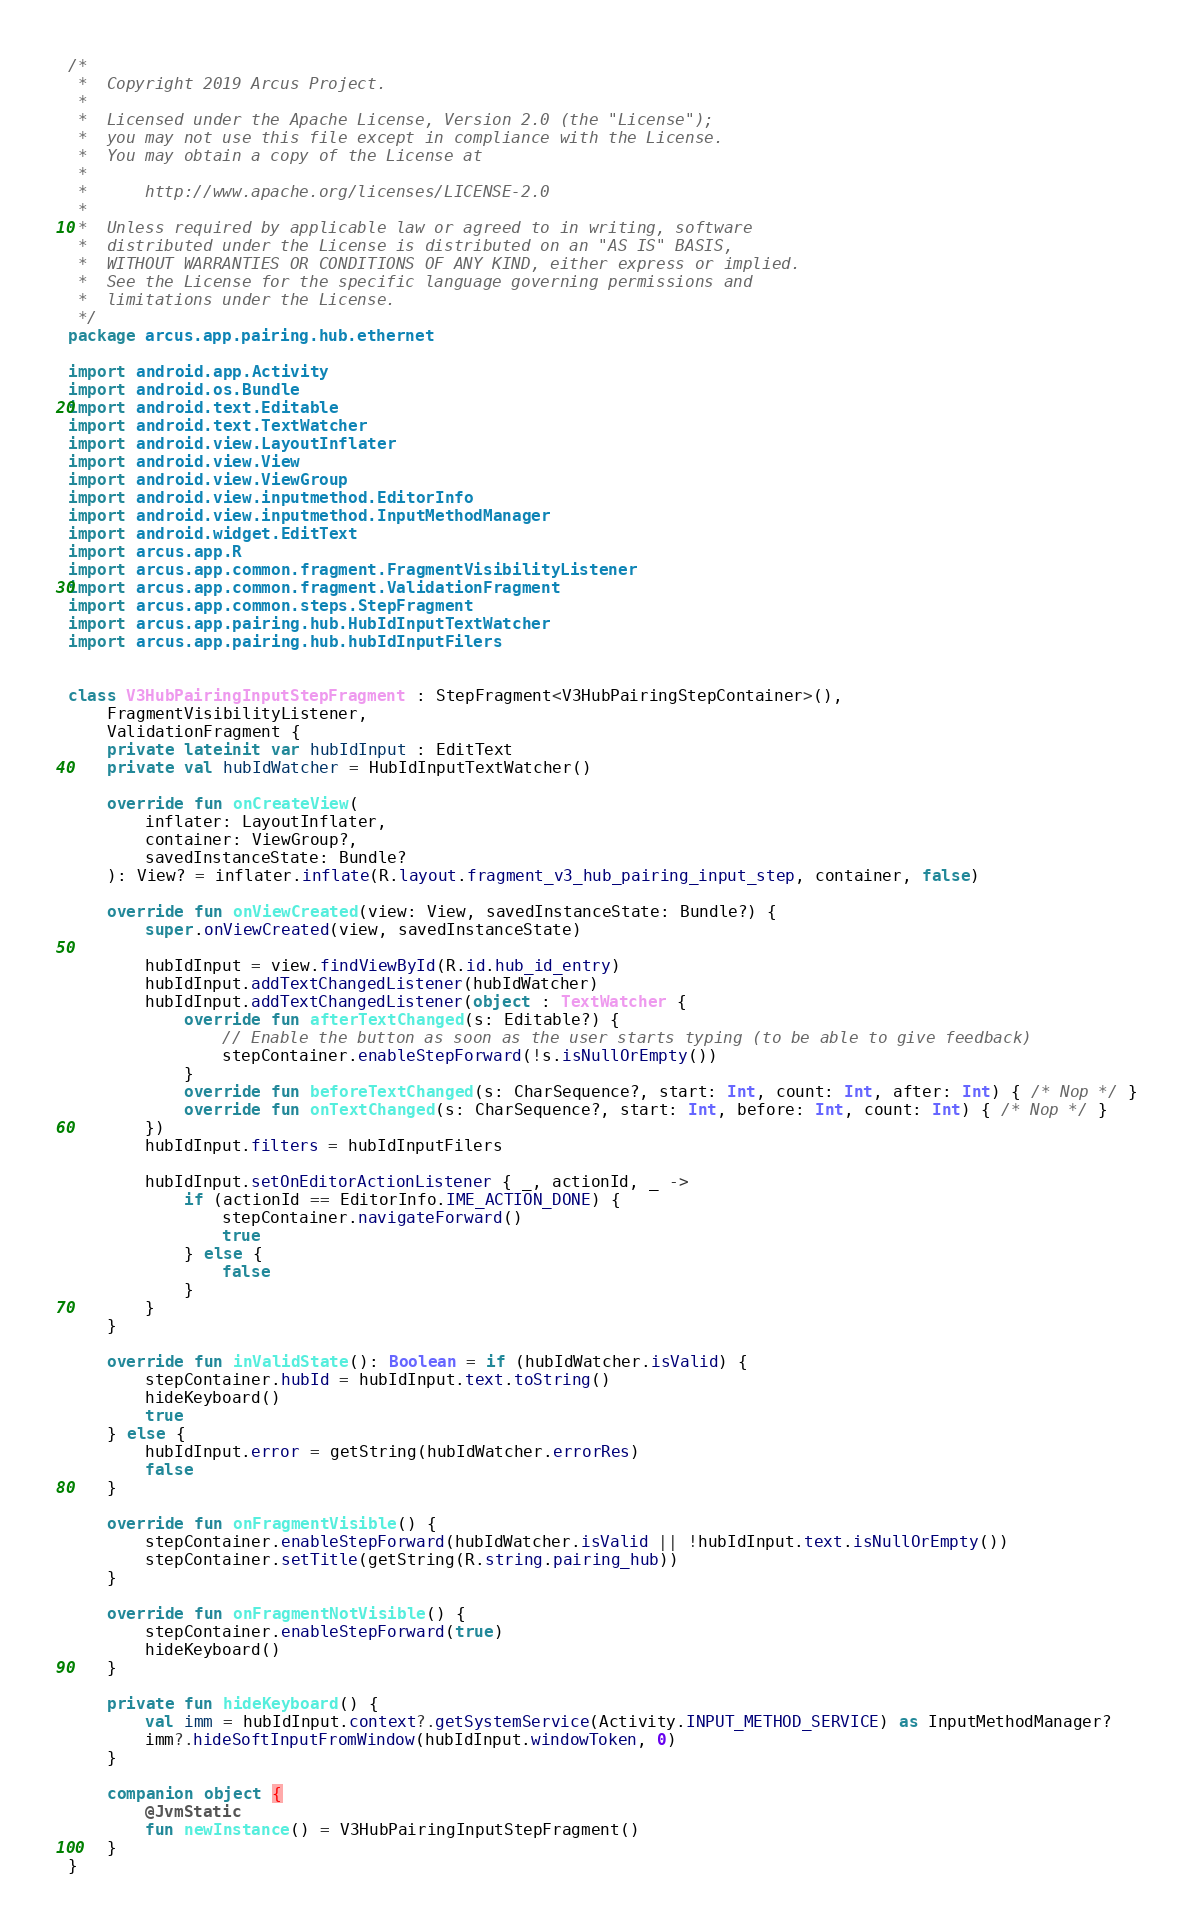Convert code to text. <code><loc_0><loc_0><loc_500><loc_500><_Kotlin_>/*
 *  Copyright 2019 Arcus Project.
 *
 *  Licensed under the Apache License, Version 2.0 (the "License");
 *  you may not use this file except in compliance with the License.
 *  You may obtain a copy of the License at
 *
 *      http://www.apache.org/licenses/LICENSE-2.0
 *
 *  Unless required by applicable law or agreed to in writing, software
 *  distributed under the License is distributed on an "AS IS" BASIS,
 *  WITHOUT WARRANTIES OR CONDITIONS OF ANY KIND, either express or implied.
 *  See the License for the specific language governing permissions and
 *  limitations under the License.
 */
package arcus.app.pairing.hub.ethernet

import android.app.Activity
import android.os.Bundle
import android.text.Editable
import android.text.TextWatcher
import android.view.LayoutInflater
import android.view.View
import android.view.ViewGroup
import android.view.inputmethod.EditorInfo
import android.view.inputmethod.InputMethodManager
import android.widget.EditText
import arcus.app.R
import arcus.app.common.fragment.FragmentVisibilityListener
import arcus.app.common.fragment.ValidationFragment
import arcus.app.common.steps.StepFragment
import arcus.app.pairing.hub.HubIdInputTextWatcher
import arcus.app.pairing.hub.hubIdInputFilers


class V3HubPairingInputStepFragment : StepFragment<V3HubPairingStepContainer>(),
    FragmentVisibilityListener,
    ValidationFragment {
    private lateinit var hubIdInput : EditText
    private val hubIdWatcher = HubIdInputTextWatcher()

    override fun onCreateView(
        inflater: LayoutInflater,
        container: ViewGroup?,
        savedInstanceState: Bundle?
    ): View? = inflater.inflate(R.layout.fragment_v3_hub_pairing_input_step, container, false)

    override fun onViewCreated(view: View, savedInstanceState: Bundle?) {
        super.onViewCreated(view, savedInstanceState)

        hubIdInput = view.findViewById(R.id.hub_id_entry)
        hubIdInput.addTextChangedListener(hubIdWatcher)
        hubIdInput.addTextChangedListener(object : TextWatcher {
            override fun afterTextChanged(s: Editable?) {
                // Enable the button as soon as the user starts typing (to be able to give feedback)
                stepContainer.enableStepForward(!s.isNullOrEmpty())
            }
            override fun beforeTextChanged(s: CharSequence?, start: Int, count: Int, after: Int) { /* Nop */ }
            override fun onTextChanged(s: CharSequence?, start: Int, before: Int, count: Int) { /* Nop */ }
        })
        hubIdInput.filters = hubIdInputFilers

        hubIdInput.setOnEditorActionListener { _, actionId, _ ->
            if (actionId == EditorInfo.IME_ACTION_DONE) {
                stepContainer.navigateForward()
                true
            } else {
                false
            }
        }
    }

    override fun inValidState(): Boolean = if (hubIdWatcher.isValid) {
        stepContainer.hubId = hubIdInput.text.toString()
        hideKeyboard()
        true
    } else {
        hubIdInput.error = getString(hubIdWatcher.errorRes)
        false
    }

    override fun onFragmentVisible() {
        stepContainer.enableStepForward(hubIdWatcher.isValid || !hubIdInput.text.isNullOrEmpty())
        stepContainer.setTitle(getString(R.string.pairing_hub))
    }

    override fun onFragmentNotVisible() {
        stepContainer.enableStepForward(true)
        hideKeyboard()
    }

    private fun hideKeyboard() {
        val imm = hubIdInput.context?.getSystemService(Activity.INPUT_METHOD_SERVICE) as InputMethodManager?
        imm?.hideSoftInputFromWindow(hubIdInput.windowToken, 0)
    }

    companion object {
        @JvmStatic
        fun newInstance() = V3HubPairingInputStepFragment()
    }
}</code> 